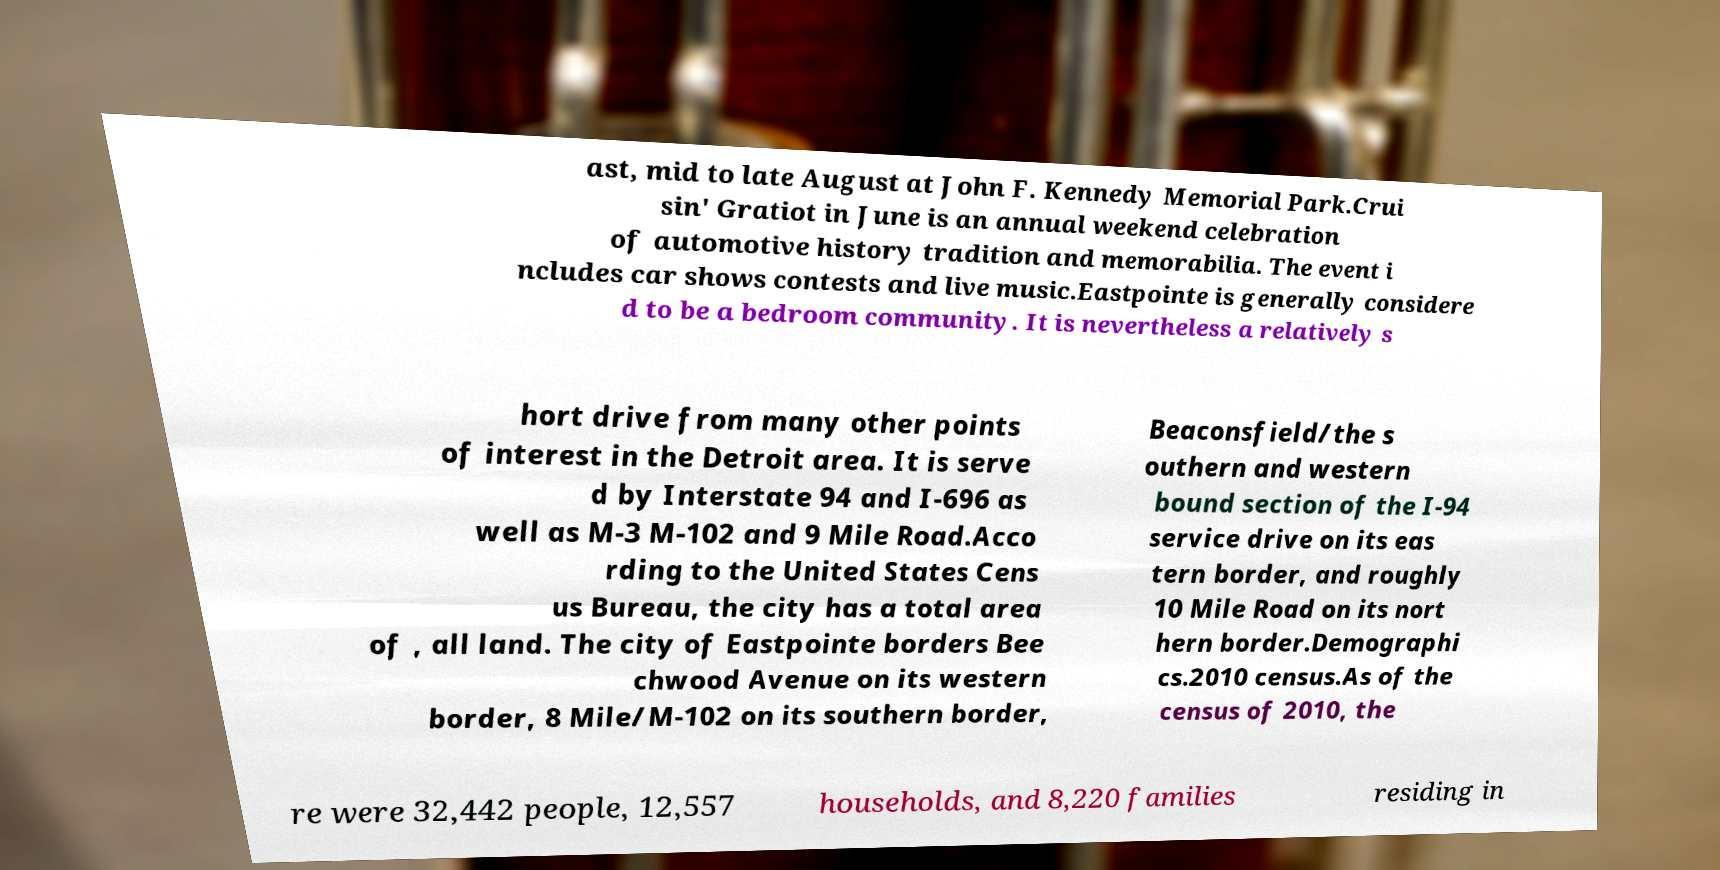Could you extract and type out the text from this image? ast, mid to late August at John F. Kennedy Memorial Park.Crui sin' Gratiot in June is an annual weekend celebration of automotive history tradition and memorabilia. The event i ncludes car shows contests and live music.Eastpointe is generally considere d to be a bedroom community. It is nevertheless a relatively s hort drive from many other points of interest in the Detroit area. It is serve d by Interstate 94 and I-696 as well as M-3 M-102 and 9 Mile Road.Acco rding to the United States Cens us Bureau, the city has a total area of , all land. The city of Eastpointe borders Bee chwood Avenue on its western border, 8 Mile/M-102 on its southern border, Beaconsfield/the s outhern and western bound section of the I-94 service drive on its eas tern border, and roughly 10 Mile Road on its nort hern border.Demographi cs.2010 census.As of the census of 2010, the re were 32,442 people, 12,557 households, and 8,220 families residing in 